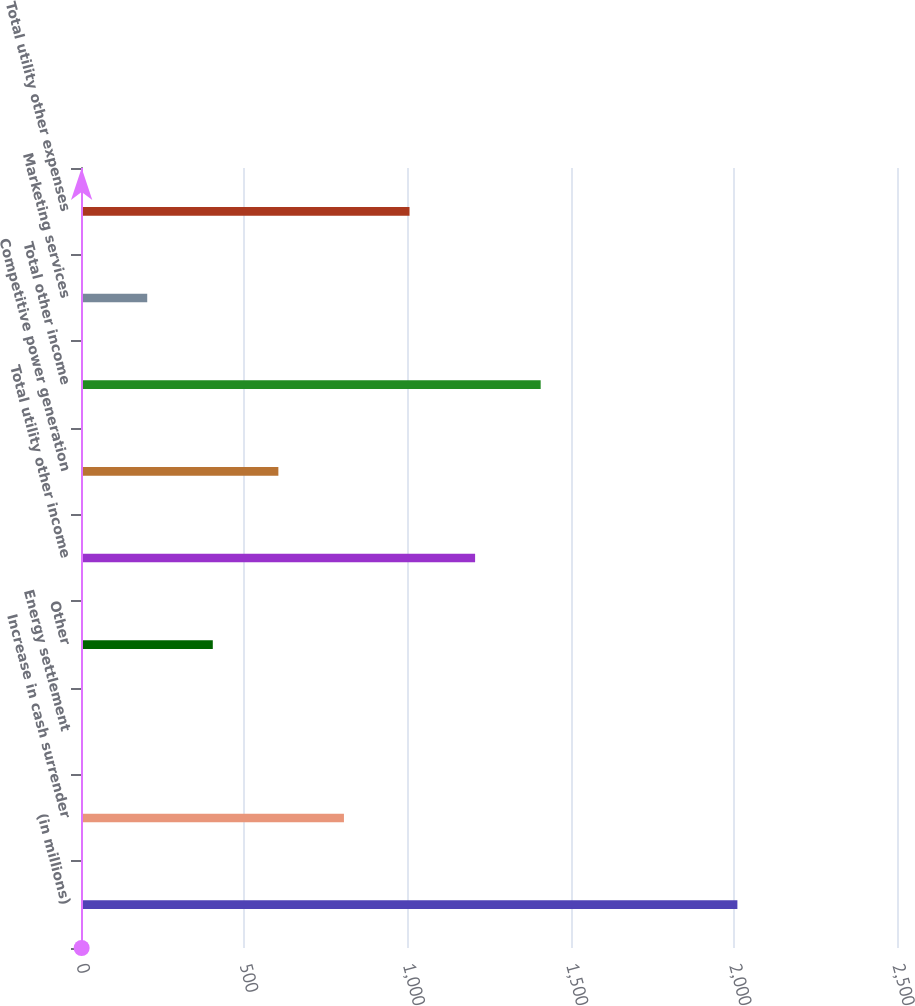<chart> <loc_0><loc_0><loc_500><loc_500><bar_chart><fcel>(in millions)<fcel>Increase in cash surrender<fcel>Energy settlement<fcel>Other<fcel>Total utility other income<fcel>Competitive power generation<fcel>Total other income<fcel>Marketing services<fcel>Total utility other expenses<nl><fcel>2011<fcel>805.6<fcel>2<fcel>403.8<fcel>1207.4<fcel>604.7<fcel>1408.3<fcel>202.9<fcel>1006.5<nl></chart> 